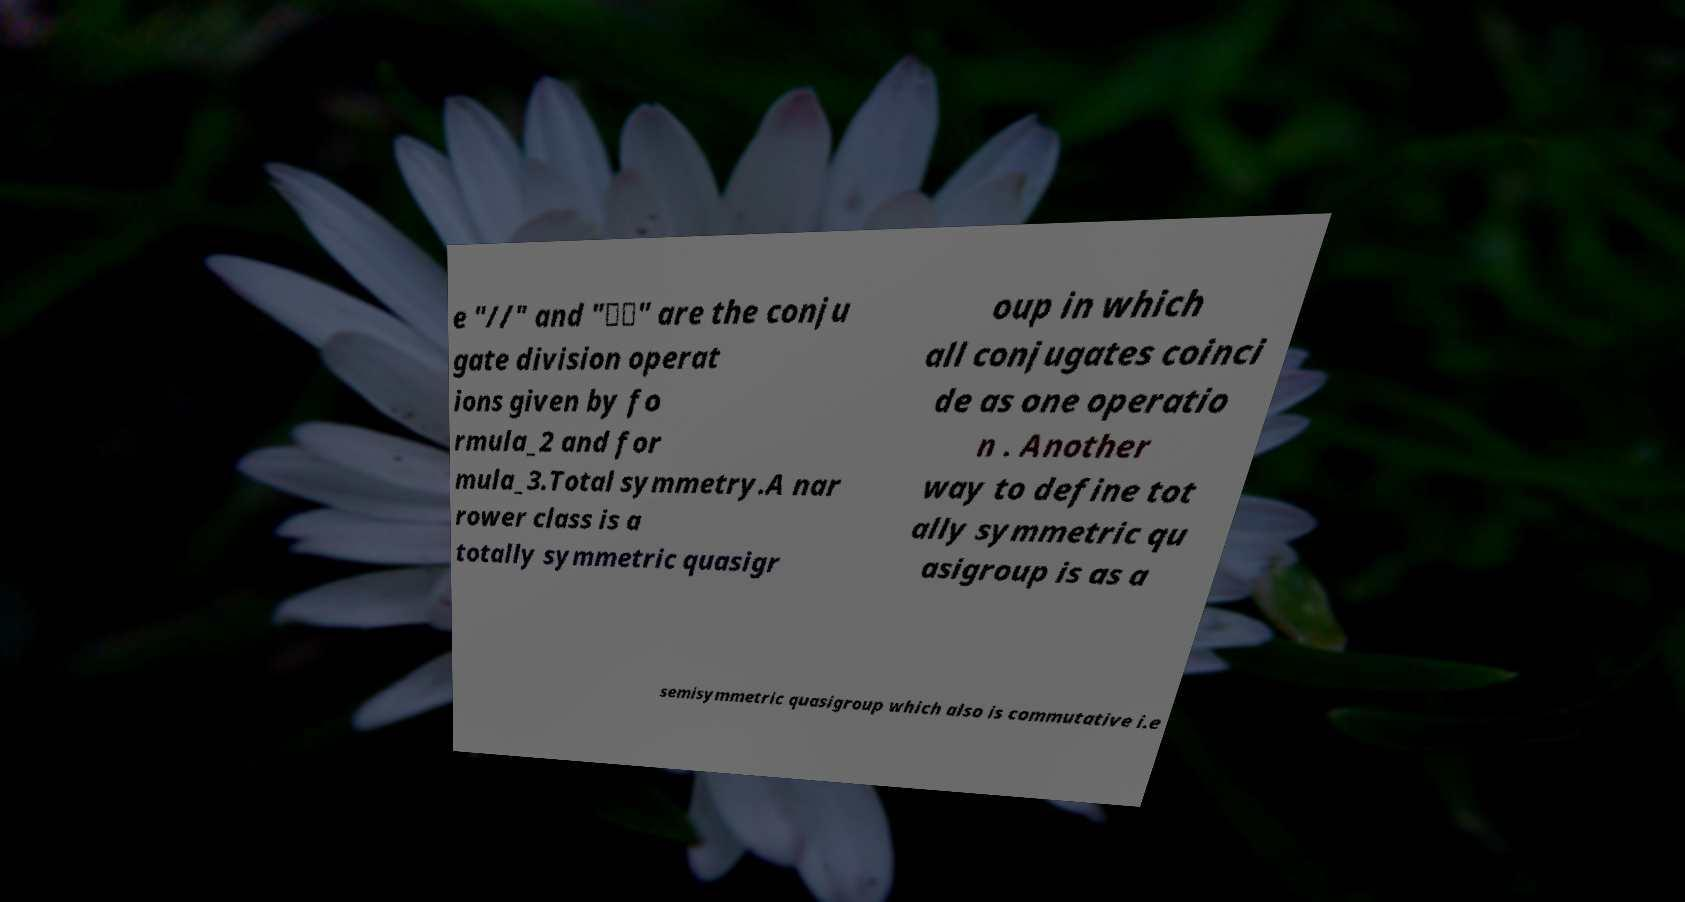Please read and relay the text visible in this image. What does it say? e "//" and "\\" are the conju gate division operat ions given by fo rmula_2 and for mula_3.Total symmetry.A nar rower class is a totally symmetric quasigr oup in which all conjugates coinci de as one operatio n . Another way to define tot ally symmetric qu asigroup is as a semisymmetric quasigroup which also is commutative i.e 